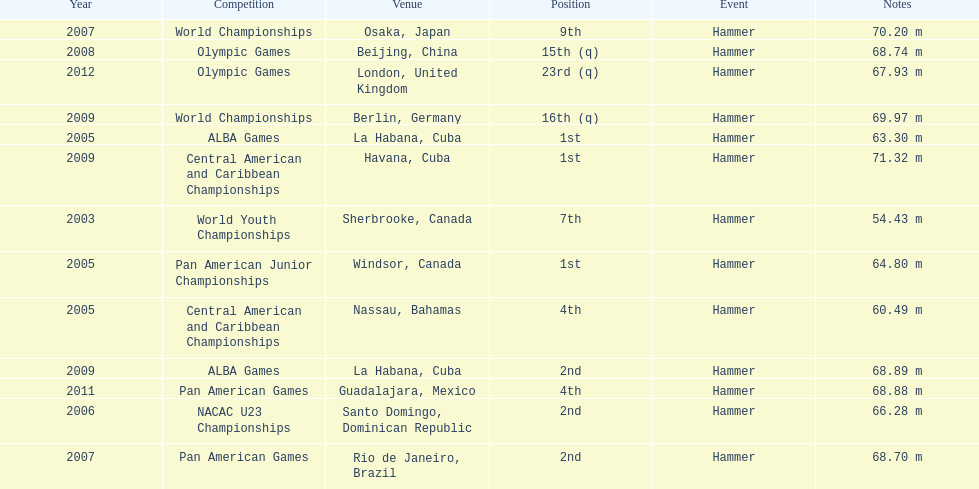In which olympic games did arasay thondike not finish in the top 20? 2012. 